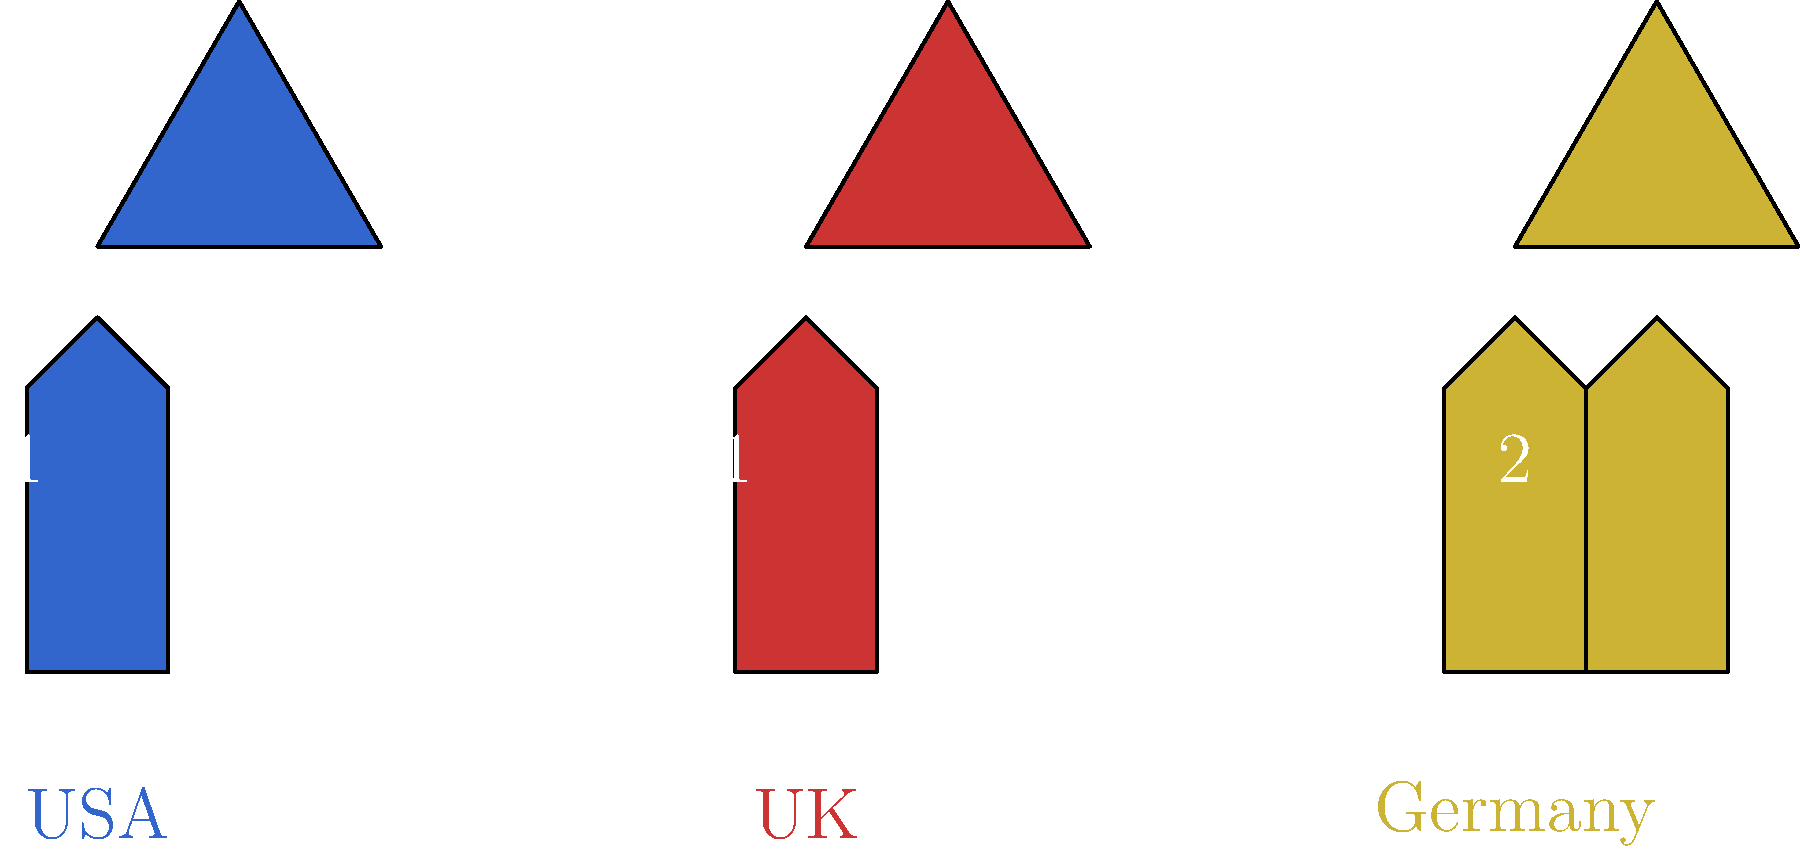Based on the graphic representation of judicial systems in the USA, UK, and Germany, which country's system suggests a higher level of judicial independence through its appointment process? To answer this question, we need to analyze the graphic and understand what it represents:

1. The scales of justice for each country are the same size, indicating similar overall judicial systems.

2. The key difference is in the number of judge figures:
   - USA has 1 judge
   - UK has 1 judge
   - Germany has 2 judges

3. The number of judges in the graphic likely represents the complexity or diversity in the judicial appointment process:
   - Single judge: Suggests a more centralized appointment process (USA and UK)
   - Two judges: Indicates a more diverse or decentralized appointment process (Germany)

4. In reality:
   - USA: Federal judges are nominated by the President and confirmed by the Senate
   - UK: Judges are appointed by an independent commission
   - Germany: Federal Constitutional Court judges are elected by both houses of parliament

5. Among these systems, Germany's process involves more diverse input (both houses of parliament), which can lead to greater judicial independence by reducing the influence of any single political entity.

Therefore, based on the graphic and our understanding of judicial systems, Germany's representation with two judges suggests a higher level of judicial independence through its appointment process.
Answer: Germany 